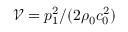Convert formula to latex. <formula><loc_0><loc_0><loc_500><loc_500>\mathcal { V } = { p _ { 1 } ^ { 2 } / ( 2 \rho _ { 0 } c _ { 0 } ^ { 2 } ) }</formula> 